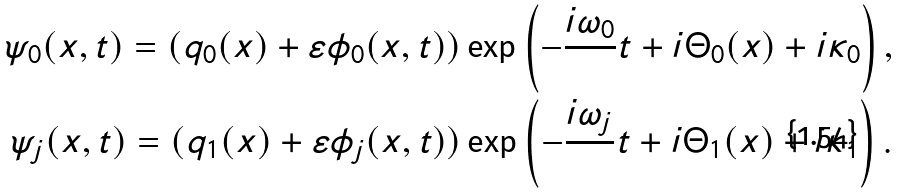<formula> <loc_0><loc_0><loc_500><loc_500>\psi _ { 0 } ( x , t ) = ( q _ { 0 } ( x ) + \varepsilon \phi _ { 0 } ( x , t ) ) \exp \left ( - \frac { i \omega _ { 0 } } { } t + i \Theta _ { 0 } ( x ) + i \kappa _ { 0 } \right ) , \\ \psi _ { j } ( x , t ) = ( q _ { 1 } ( x ) + \varepsilon \phi _ { j } ( x , t ) ) \exp \left ( - \frac { i \omega _ { j } } { } t + i \Theta _ { 1 } ( x ) + i \kappa _ { 1 } \right ) .</formula> 